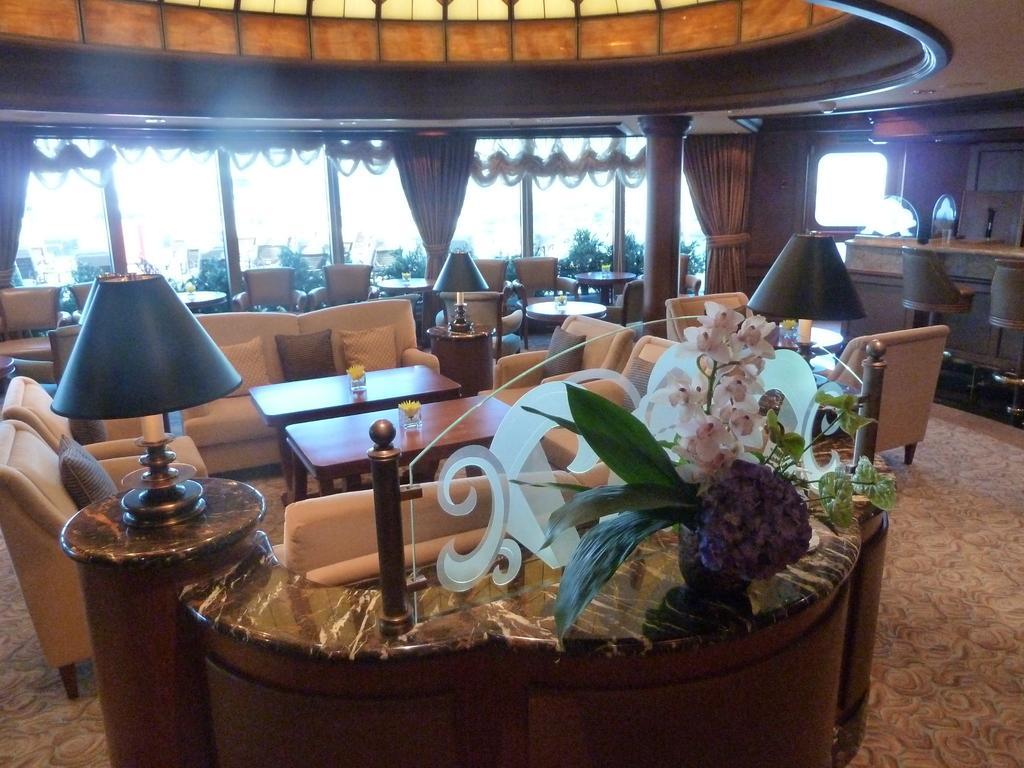In one or two sentences, can you explain what this image depicts? There are sofas and tables, there are lamps, this is a plant, these are curtains and chairs. 